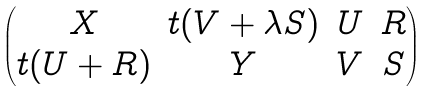<formula> <loc_0><loc_0><loc_500><loc_500>\begin{pmatrix} X & t ( V + \lambda S ) & U & R \\ t ( U + R ) & Y & V & S \end{pmatrix}</formula> 